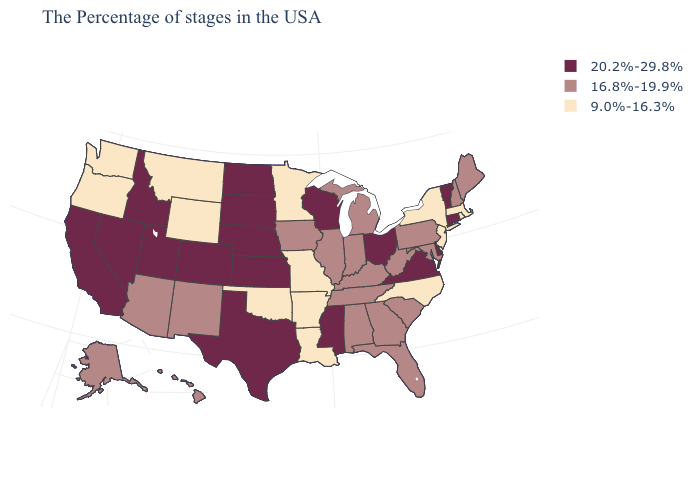How many symbols are there in the legend?
Quick response, please. 3. How many symbols are there in the legend?
Give a very brief answer. 3. What is the lowest value in states that border Tennessee?
Quick response, please. 9.0%-16.3%. Name the states that have a value in the range 9.0%-16.3%?
Concise answer only. Massachusetts, Rhode Island, New York, New Jersey, North Carolina, Louisiana, Missouri, Arkansas, Minnesota, Oklahoma, Wyoming, Montana, Washington, Oregon. Name the states that have a value in the range 16.8%-19.9%?
Be succinct. Maine, New Hampshire, Maryland, Pennsylvania, South Carolina, West Virginia, Florida, Georgia, Michigan, Kentucky, Indiana, Alabama, Tennessee, Illinois, Iowa, New Mexico, Arizona, Alaska, Hawaii. What is the value of Maryland?
Be succinct. 16.8%-19.9%. What is the lowest value in the South?
Write a very short answer. 9.0%-16.3%. What is the highest value in the Northeast ?
Keep it brief. 20.2%-29.8%. Is the legend a continuous bar?
Keep it brief. No. Which states have the lowest value in the MidWest?
Short answer required. Missouri, Minnesota. Which states have the highest value in the USA?
Quick response, please. Vermont, Connecticut, Delaware, Virginia, Ohio, Wisconsin, Mississippi, Kansas, Nebraska, Texas, South Dakota, North Dakota, Colorado, Utah, Idaho, Nevada, California. What is the value of Oklahoma?
Be succinct. 9.0%-16.3%. Does Colorado have the highest value in the West?
Answer briefly. Yes. What is the value of New Hampshire?
Write a very short answer. 16.8%-19.9%. Name the states that have a value in the range 16.8%-19.9%?
Give a very brief answer. Maine, New Hampshire, Maryland, Pennsylvania, South Carolina, West Virginia, Florida, Georgia, Michigan, Kentucky, Indiana, Alabama, Tennessee, Illinois, Iowa, New Mexico, Arizona, Alaska, Hawaii. 